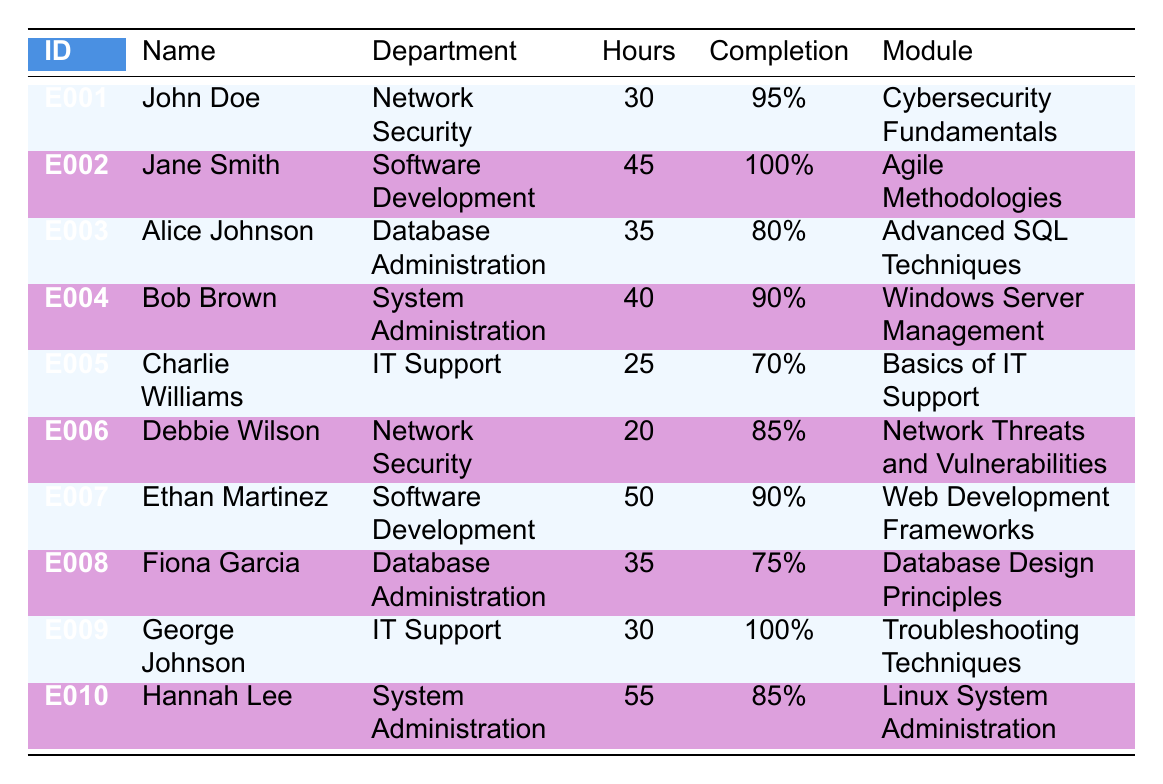What is the total number of training hours for employees in the Software Development department? From the table, the training hours for employees in the Software Development department are Jane Smith (45 hours) and Ethan Martinez (50 hours). Adding these gives 45 + 50 = 95 hours.
Answer: 95 hours Which employee has the highest completion rate? By comparing the completion rates listed in the table, Jane Smith has a completion rate of 100%, which is higher than all others.
Answer: Jane Smith What is the average completion rate for employees in the Database Administration department? Alice Johnson has a completion rate of 80%, and Fiona Garcia has a completion rate of 75%. To find the average, sum 80 and 75 to get 155, then divide by 2 for the average: 155 / 2 = 77.5%.
Answer: 77.5% Did any employee in the IT Support department complete their training with over 80%? George Johnson completed his training with a rate of 100%, which is over 80%. Charlie Williams has a completion rate of 70%, which is not over 80%. Thus, the statement is true.
Answer: Yes How many employees completed their training with a completion rate below 80%? Alice Johnson (80%), Fiona Garcia (75%), and Charlie Williams (70%) are below 80%, totaling 3 employees.
Answer: 2 employees 